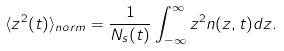<formula> <loc_0><loc_0><loc_500><loc_500>\langle z ^ { 2 } ( t ) \rangle _ { n o r m } = \frac { 1 } { N _ { s } ( t ) } \int _ { - \infty } ^ { \infty } z ^ { 2 } n ( z , t ) d z .</formula> 